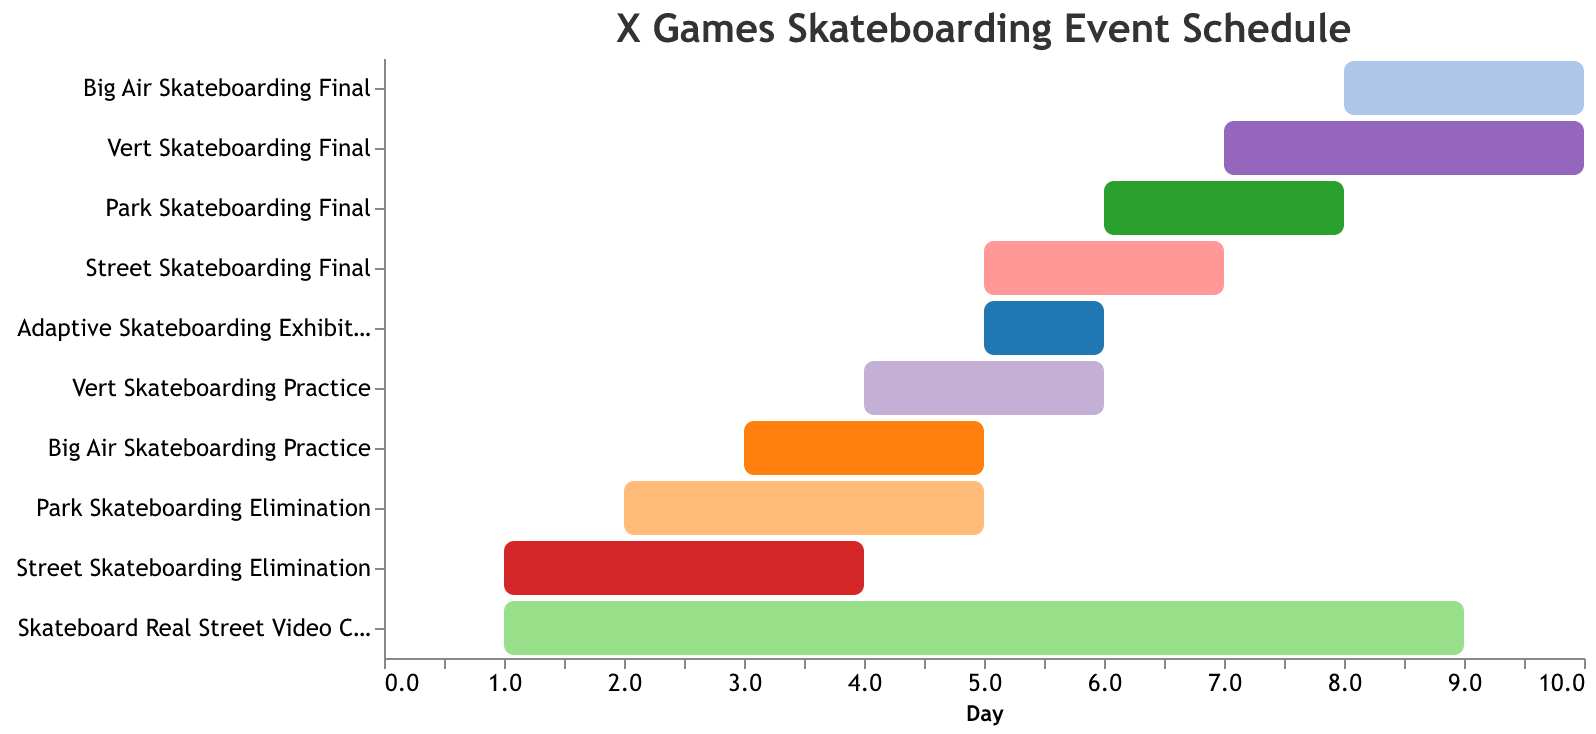What is the duration of the Street Skateboarding Elimination event? According to the figure, the duration of the Street Skateboarding Elimination event can be seen by the length of its bar, which spans 3 days.
Answer: 3 days On which day does the Park Skateboarding Final event start? The Park Skateboarding Final event starts on the 6th day as indicated by its position on the x-axis.
Answer: 6th day Which event has the longest duration? The Skateboard Real Street Video Contest occupies the longest duration as its bar stretches from day 1 to day 8, covering 8 days.
Answer: Skateboard Real Street Video Contest How many events start on day 1? To find the number of events starting on day 1, we identify the bars that begin at the 1 position on the x-axis. These events are Street Skateboarding Elimination and Skateboard Real Street Video Contest.
Answer: 2 events Which event starts earlier, Vert Skateboarding Practice or Park Skateboarding Elimination? By comparing the x-axis start positions, Park Skateboarding Elimination begins on day 2, whereas Vert Skateboarding Practice starts on day 4. So, Park Skateboarding Elimination starts earlier.
Answer: Park Skateboarding Elimination How many days does the entire X Games Skateboarding event schedule cover? The entire X Games Skateboarding event spans from the earliest start of day 1 to the latest end of day 10, covered by the Skateboard Real Street Video Contest.
Answer: 10 days What is the time gap between the end of the Street Skateboarding Elimination and the start of the Street Skateboarding Final? Street Skateboarding Elimination ends on day 4 (1 + 3), and Street Skateboarding Final starts on day 5. The gap is 1 day.
Answer: 1 day Compare the duration of the Big Air Skateboarding Final and the Adaptive Skateboarding Exhibition. Which one is longer? The Big Air Skateboarding Final has a duration of 2 days, while the Adaptive Skateboarding Exhibition lasts for 1 day. Thus, the Big Air Skateboarding Final is longer.
Answer: Big Air Skateboarding Final If a participant wants to compete in both Street Skateboarding Final and Adaptive Skateboarding Exhibition, does the schedule allow it based on their start and end times? Both events start on day 5, and the Street Skateboarding Final spans 2 days, while the Adaptive Skateboarding Exhibition lasts for 1 day concurrently with the first day of the final. The participant can attend both without schedule conflicts.
Answer: Yes 